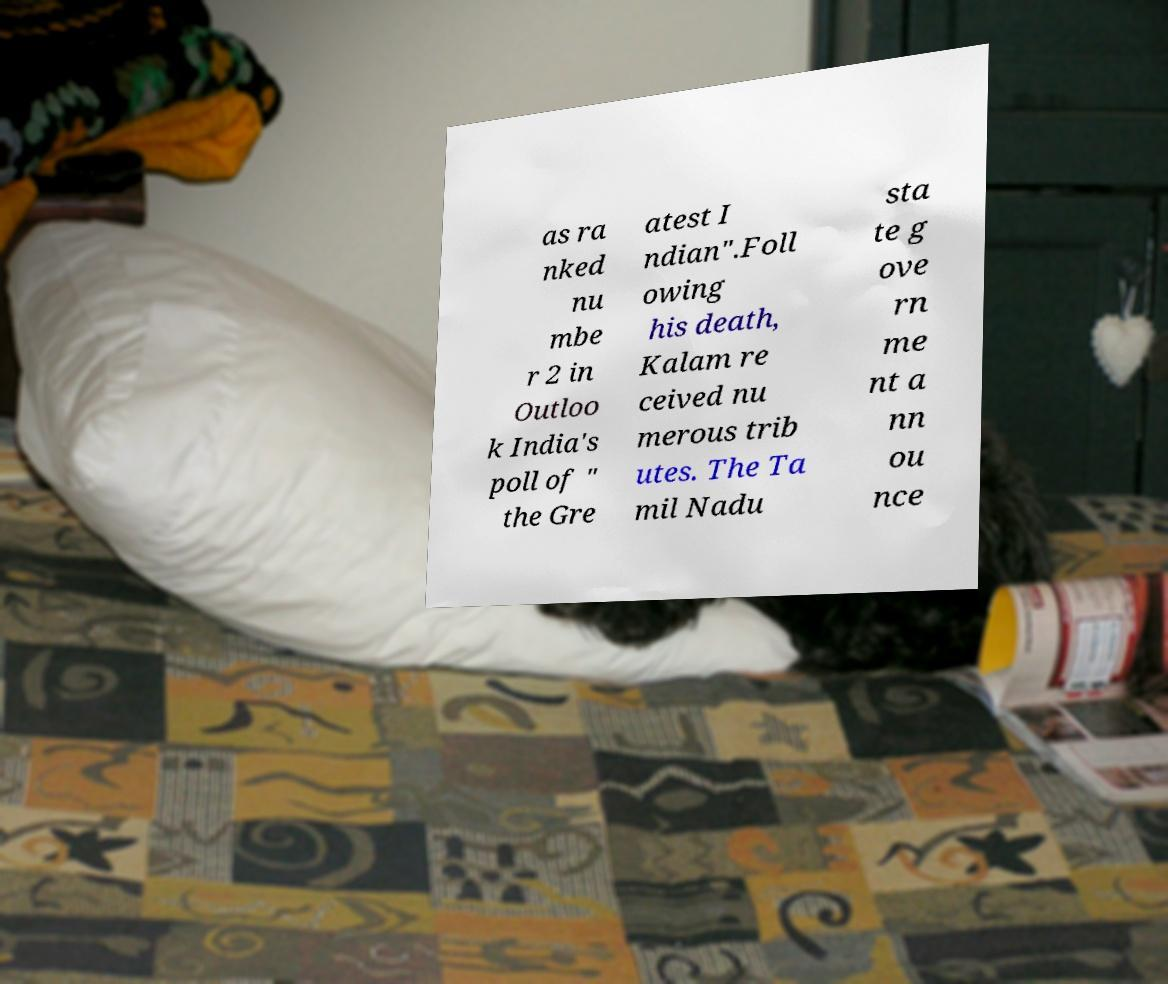Could you assist in decoding the text presented in this image and type it out clearly? as ra nked nu mbe r 2 in Outloo k India's poll of " the Gre atest I ndian".Foll owing his death, Kalam re ceived nu merous trib utes. The Ta mil Nadu sta te g ove rn me nt a nn ou nce 